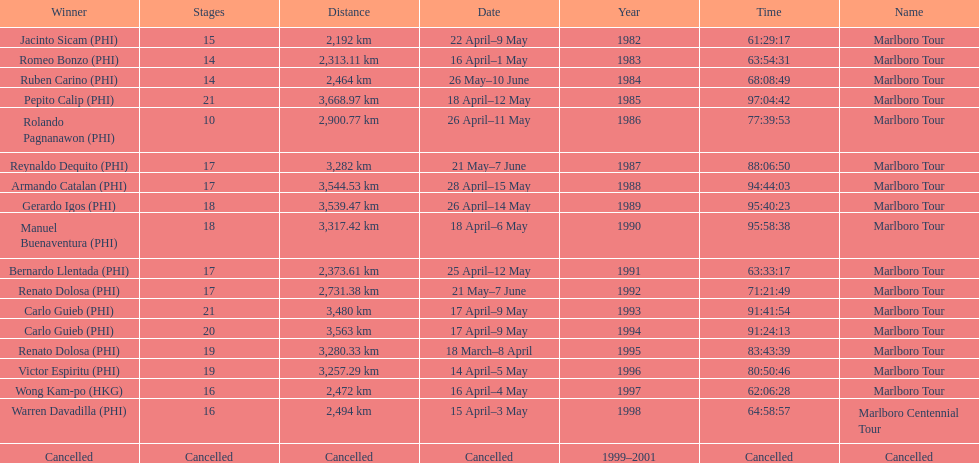Write the full table. {'header': ['Winner', 'Stages', 'Distance', 'Date', 'Year', 'Time', 'Name'], 'rows': [['Jacinto Sicam\xa0(PHI)', '15', '2,192\xa0km', '22 April–9 May', '1982', '61:29:17', 'Marlboro Tour'], ['Romeo Bonzo\xa0(PHI)', '14', '2,313.11\xa0km', '16 April–1 May', '1983', '63:54:31', 'Marlboro Tour'], ['Ruben Carino\xa0(PHI)', '14', '2,464\xa0km', '26 May–10 June', '1984', '68:08:49', 'Marlboro Tour'], ['Pepito Calip\xa0(PHI)', '21', '3,668.97\xa0km', '18 April–12 May', '1985', '97:04:42', 'Marlboro Tour'], ['Rolando Pagnanawon\xa0(PHI)', '10', '2,900.77\xa0km', '26 April–11 May', '1986', '77:39:53', 'Marlboro Tour'], ['Reynaldo Dequito\xa0(PHI)', '17', '3,282\xa0km', '21 May–7 June', '1987', '88:06:50', 'Marlboro Tour'], ['Armando Catalan\xa0(PHI)', '17', '3,544.53\xa0km', '28 April–15 May', '1988', '94:44:03', 'Marlboro Tour'], ['Gerardo Igos\xa0(PHI)', '18', '3,539.47\xa0km', '26 April–14 May', '1989', '95:40:23', 'Marlboro Tour'], ['Manuel Buenaventura\xa0(PHI)', '18', '3,317.42\xa0km', '18 April–6 May', '1990', '95:58:38', 'Marlboro Tour'], ['Bernardo Llentada\xa0(PHI)', '17', '2,373.61\xa0km', '25 April–12 May', '1991', '63:33:17', 'Marlboro Tour'], ['Renato Dolosa\xa0(PHI)', '17', '2,731.38\xa0km', '21 May–7 June', '1992', '71:21:49', 'Marlboro Tour'], ['Carlo Guieb\xa0(PHI)', '21', '3,480\xa0km', '17 April–9 May', '1993', '91:41:54', 'Marlboro Tour'], ['Carlo Guieb\xa0(PHI)', '20', '3,563\xa0km', '17 April–9 May', '1994', '91:24:13', 'Marlboro Tour'], ['Renato Dolosa\xa0(PHI)', '19', '3,280.33\xa0km', '18 March–8 April', '1995', '83:43:39', 'Marlboro Tour'], ['Victor Espiritu\xa0(PHI)', '19', '3,257.29\xa0km', '14 April–5 May', '1996', '80:50:46', 'Marlboro Tour'], ['Wong Kam-po\xa0(HKG)', '16', '2,472\xa0km', '16 April–4 May', '1997', '62:06:28', 'Marlboro Tour'], ['Warren Davadilla\xa0(PHI)', '16', '2,494\xa0km', '15 April–3 May', '1998', '64:58:57', 'Marlboro Centennial Tour'], ['Cancelled', 'Cancelled', 'Cancelled', 'Cancelled', '1999–2001', 'Cancelled', 'Cancelled']]} What was the largest distance traveled for the marlboro tour? 3,668.97 km. 